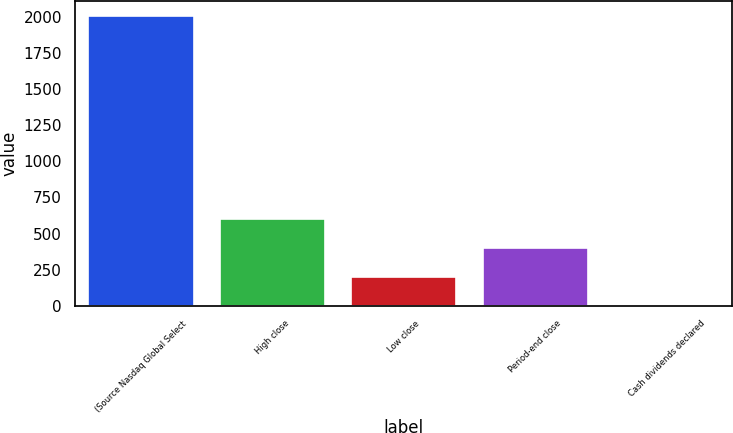Convert chart to OTSL. <chart><loc_0><loc_0><loc_500><loc_500><bar_chart><fcel>(Source Nasdaq Global Select<fcel>High close<fcel>Low close<fcel>Period-end close<fcel>Cash dividends declared<nl><fcel>2007<fcel>602.36<fcel>201.02<fcel>401.69<fcel>0.35<nl></chart> 